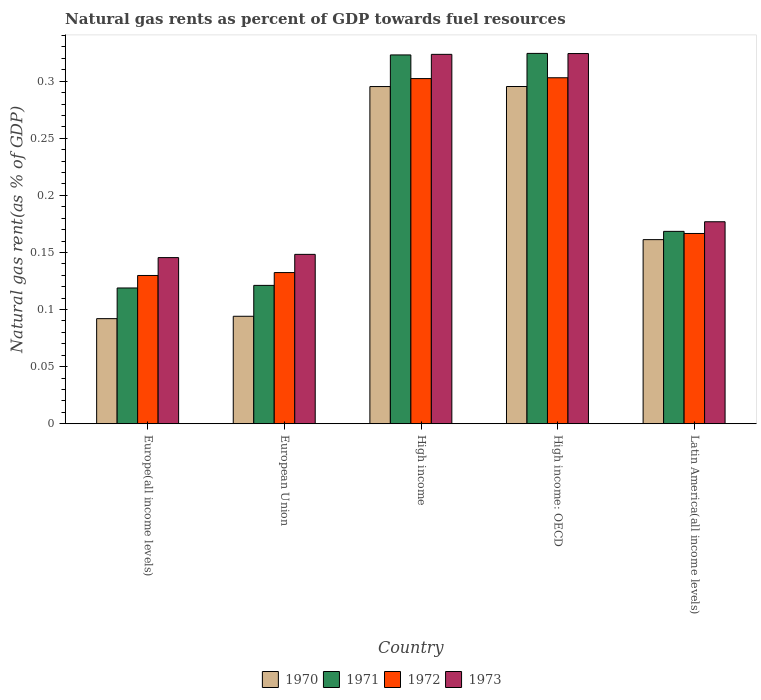How many different coloured bars are there?
Keep it short and to the point. 4. How many groups of bars are there?
Give a very brief answer. 5. Are the number of bars per tick equal to the number of legend labels?
Your answer should be very brief. Yes. Are the number of bars on each tick of the X-axis equal?
Your answer should be compact. Yes. How many bars are there on the 4th tick from the left?
Offer a very short reply. 4. What is the label of the 1st group of bars from the left?
Your answer should be very brief. Europe(all income levels). What is the natural gas rent in 1971 in High income: OECD?
Provide a short and direct response. 0.32. Across all countries, what is the maximum natural gas rent in 1973?
Your answer should be compact. 0.32. Across all countries, what is the minimum natural gas rent in 1971?
Give a very brief answer. 0.12. In which country was the natural gas rent in 1970 maximum?
Your answer should be compact. High income: OECD. In which country was the natural gas rent in 1970 minimum?
Offer a terse response. Europe(all income levels). What is the total natural gas rent in 1970 in the graph?
Keep it short and to the point. 0.94. What is the difference between the natural gas rent in 1970 in European Union and that in High income: OECD?
Keep it short and to the point. -0.2. What is the difference between the natural gas rent in 1972 in Europe(all income levels) and the natural gas rent in 1970 in European Union?
Your response must be concise. 0.04. What is the average natural gas rent in 1972 per country?
Ensure brevity in your answer.  0.21. What is the difference between the natural gas rent of/in 1973 and natural gas rent of/in 1971 in Europe(all income levels)?
Offer a very short reply. 0.03. What is the ratio of the natural gas rent in 1971 in Europe(all income levels) to that in Latin America(all income levels)?
Your answer should be compact. 0.71. What is the difference between the highest and the second highest natural gas rent in 1970?
Provide a short and direct response. 0.13. What is the difference between the highest and the lowest natural gas rent in 1972?
Provide a short and direct response. 0.17. In how many countries, is the natural gas rent in 1973 greater than the average natural gas rent in 1973 taken over all countries?
Offer a very short reply. 2. What does the 3rd bar from the left in Europe(all income levels) represents?
Your answer should be compact. 1972. What does the 1st bar from the right in High income represents?
Provide a short and direct response. 1973. How many bars are there?
Your response must be concise. 20. How many countries are there in the graph?
Ensure brevity in your answer.  5. What is the difference between two consecutive major ticks on the Y-axis?
Ensure brevity in your answer.  0.05. Are the values on the major ticks of Y-axis written in scientific E-notation?
Keep it short and to the point. No. Does the graph contain any zero values?
Ensure brevity in your answer.  No. Where does the legend appear in the graph?
Offer a very short reply. Bottom center. How many legend labels are there?
Offer a terse response. 4. How are the legend labels stacked?
Offer a terse response. Horizontal. What is the title of the graph?
Offer a terse response. Natural gas rents as percent of GDP towards fuel resources. What is the label or title of the X-axis?
Provide a short and direct response. Country. What is the label or title of the Y-axis?
Make the answer very short. Natural gas rent(as % of GDP). What is the Natural gas rent(as % of GDP) in 1970 in Europe(all income levels)?
Your response must be concise. 0.09. What is the Natural gas rent(as % of GDP) of 1971 in Europe(all income levels)?
Your answer should be very brief. 0.12. What is the Natural gas rent(as % of GDP) of 1972 in Europe(all income levels)?
Provide a succinct answer. 0.13. What is the Natural gas rent(as % of GDP) of 1973 in Europe(all income levels)?
Ensure brevity in your answer.  0.15. What is the Natural gas rent(as % of GDP) of 1970 in European Union?
Provide a short and direct response. 0.09. What is the Natural gas rent(as % of GDP) of 1971 in European Union?
Ensure brevity in your answer.  0.12. What is the Natural gas rent(as % of GDP) in 1972 in European Union?
Provide a succinct answer. 0.13. What is the Natural gas rent(as % of GDP) of 1973 in European Union?
Offer a terse response. 0.15. What is the Natural gas rent(as % of GDP) in 1970 in High income?
Keep it short and to the point. 0.3. What is the Natural gas rent(as % of GDP) of 1971 in High income?
Offer a terse response. 0.32. What is the Natural gas rent(as % of GDP) in 1972 in High income?
Give a very brief answer. 0.3. What is the Natural gas rent(as % of GDP) in 1973 in High income?
Your response must be concise. 0.32. What is the Natural gas rent(as % of GDP) in 1970 in High income: OECD?
Give a very brief answer. 0.3. What is the Natural gas rent(as % of GDP) in 1971 in High income: OECD?
Ensure brevity in your answer.  0.32. What is the Natural gas rent(as % of GDP) of 1972 in High income: OECD?
Your answer should be very brief. 0.3. What is the Natural gas rent(as % of GDP) of 1973 in High income: OECD?
Keep it short and to the point. 0.32. What is the Natural gas rent(as % of GDP) in 1970 in Latin America(all income levels)?
Offer a terse response. 0.16. What is the Natural gas rent(as % of GDP) of 1971 in Latin America(all income levels)?
Offer a very short reply. 0.17. What is the Natural gas rent(as % of GDP) of 1972 in Latin America(all income levels)?
Provide a succinct answer. 0.17. What is the Natural gas rent(as % of GDP) of 1973 in Latin America(all income levels)?
Offer a terse response. 0.18. Across all countries, what is the maximum Natural gas rent(as % of GDP) in 1970?
Keep it short and to the point. 0.3. Across all countries, what is the maximum Natural gas rent(as % of GDP) in 1971?
Keep it short and to the point. 0.32. Across all countries, what is the maximum Natural gas rent(as % of GDP) in 1972?
Offer a terse response. 0.3. Across all countries, what is the maximum Natural gas rent(as % of GDP) in 1973?
Ensure brevity in your answer.  0.32. Across all countries, what is the minimum Natural gas rent(as % of GDP) in 1970?
Offer a terse response. 0.09. Across all countries, what is the minimum Natural gas rent(as % of GDP) in 1971?
Your answer should be very brief. 0.12. Across all countries, what is the minimum Natural gas rent(as % of GDP) in 1972?
Keep it short and to the point. 0.13. Across all countries, what is the minimum Natural gas rent(as % of GDP) in 1973?
Offer a terse response. 0.15. What is the total Natural gas rent(as % of GDP) in 1970 in the graph?
Offer a very short reply. 0.94. What is the total Natural gas rent(as % of GDP) in 1971 in the graph?
Ensure brevity in your answer.  1.06. What is the total Natural gas rent(as % of GDP) in 1972 in the graph?
Your answer should be compact. 1.03. What is the total Natural gas rent(as % of GDP) of 1973 in the graph?
Provide a succinct answer. 1.12. What is the difference between the Natural gas rent(as % of GDP) in 1970 in Europe(all income levels) and that in European Union?
Give a very brief answer. -0. What is the difference between the Natural gas rent(as % of GDP) in 1971 in Europe(all income levels) and that in European Union?
Your response must be concise. -0. What is the difference between the Natural gas rent(as % of GDP) in 1972 in Europe(all income levels) and that in European Union?
Offer a very short reply. -0. What is the difference between the Natural gas rent(as % of GDP) in 1973 in Europe(all income levels) and that in European Union?
Offer a terse response. -0. What is the difference between the Natural gas rent(as % of GDP) in 1970 in Europe(all income levels) and that in High income?
Give a very brief answer. -0.2. What is the difference between the Natural gas rent(as % of GDP) in 1971 in Europe(all income levels) and that in High income?
Your answer should be very brief. -0.2. What is the difference between the Natural gas rent(as % of GDP) in 1972 in Europe(all income levels) and that in High income?
Your answer should be very brief. -0.17. What is the difference between the Natural gas rent(as % of GDP) of 1973 in Europe(all income levels) and that in High income?
Provide a succinct answer. -0.18. What is the difference between the Natural gas rent(as % of GDP) of 1970 in Europe(all income levels) and that in High income: OECD?
Your response must be concise. -0.2. What is the difference between the Natural gas rent(as % of GDP) of 1971 in Europe(all income levels) and that in High income: OECD?
Keep it short and to the point. -0.21. What is the difference between the Natural gas rent(as % of GDP) in 1972 in Europe(all income levels) and that in High income: OECD?
Keep it short and to the point. -0.17. What is the difference between the Natural gas rent(as % of GDP) in 1973 in Europe(all income levels) and that in High income: OECD?
Provide a short and direct response. -0.18. What is the difference between the Natural gas rent(as % of GDP) of 1970 in Europe(all income levels) and that in Latin America(all income levels)?
Offer a very short reply. -0.07. What is the difference between the Natural gas rent(as % of GDP) of 1971 in Europe(all income levels) and that in Latin America(all income levels)?
Your response must be concise. -0.05. What is the difference between the Natural gas rent(as % of GDP) of 1972 in Europe(all income levels) and that in Latin America(all income levels)?
Make the answer very short. -0.04. What is the difference between the Natural gas rent(as % of GDP) in 1973 in Europe(all income levels) and that in Latin America(all income levels)?
Make the answer very short. -0.03. What is the difference between the Natural gas rent(as % of GDP) of 1970 in European Union and that in High income?
Provide a short and direct response. -0.2. What is the difference between the Natural gas rent(as % of GDP) in 1971 in European Union and that in High income?
Ensure brevity in your answer.  -0.2. What is the difference between the Natural gas rent(as % of GDP) in 1972 in European Union and that in High income?
Your response must be concise. -0.17. What is the difference between the Natural gas rent(as % of GDP) in 1973 in European Union and that in High income?
Offer a terse response. -0.18. What is the difference between the Natural gas rent(as % of GDP) in 1970 in European Union and that in High income: OECD?
Offer a terse response. -0.2. What is the difference between the Natural gas rent(as % of GDP) in 1971 in European Union and that in High income: OECD?
Give a very brief answer. -0.2. What is the difference between the Natural gas rent(as % of GDP) in 1972 in European Union and that in High income: OECD?
Your answer should be compact. -0.17. What is the difference between the Natural gas rent(as % of GDP) of 1973 in European Union and that in High income: OECD?
Offer a terse response. -0.18. What is the difference between the Natural gas rent(as % of GDP) in 1970 in European Union and that in Latin America(all income levels)?
Your answer should be compact. -0.07. What is the difference between the Natural gas rent(as % of GDP) in 1971 in European Union and that in Latin America(all income levels)?
Make the answer very short. -0.05. What is the difference between the Natural gas rent(as % of GDP) of 1972 in European Union and that in Latin America(all income levels)?
Make the answer very short. -0.03. What is the difference between the Natural gas rent(as % of GDP) of 1973 in European Union and that in Latin America(all income levels)?
Offer a terse response. -0.03. What is the difference between the Natural gas rent(as % of GDP) in 1971 in High income and that in High income: OECD?
Your response must be concise. -0. What is the difference between the Natural gas rent(as % of GDP) of 1972 in High income and that in High income: OECD?
Your answer should be compact. -0. What is the difference between the Natural gas rent(as % of GDP) in 1973 in High income and that in High income: OECD?
Your answer should be very brief. -0. What is the difference between the Natural gas rent(as % of GDP) in 1970 in High income and that in Latin America(all income levels)?
Give a very brief answer. 0.13. What is the difference between the Natural gas rent(as % of GDP) of 1971 in High income and that in Latin America(all income levels)?
Your answer should be compact. 0.15. What is the difference between the Natural gas rent(as % of GDP) in 1972 in High income and that in Latin America(all income levels)?
Keep it short and to the point. 0.14. What is the difference between the Natural gas rent(as % of GDP) in 1973 in High income and that in Latin America(all income levels)?
Provide a succinct answer. 0.15. What is the difference between the Natural gas rent(as % of GDP) of 1970 in High income: OECD and that in Latin America(all income levels)?
Provide a succinct answer. 0.13. What is the difference between the Natural gas rent(as % of GDP) of 1971 in High income: OECD and that in Latin America(all income levels)?
Provide a succinct answer. 0.16. What is the difference between the Natural gas rent(as % of GDP) in 1972 in High income: OECD and that in Latin America(all income levels)?
Provide a succinct answer. 0.14. What is the difference between the Natural gas rent(as % of GDP) of 1973 in High income: OECD and that in Latin America(all income levels)?
Offer a terse response. 0.15. What is the difference between the Natural gas rent(as % of GDP) in 1970 in Europe(all income levels) and the Natural gas rent(as % of GDP) in 1971 in European Union?
Give a very brief answer. -0.03. What is the difference between the Natural gas rent(as % of GDP) of 1970 in Europe(all income levels) and the Natural gas rent(as % of GDP) of 1972 in European Union?
Provide a short and direct response. -0.04. What is the difference between the Natural gas rent(as % of GDP) in 1970 in Europe(all income levels) and the Natural gas rent(as % of GDP) in 1973 in European Union?
Make the answer very short. -0.06. What is the difference between the Natural gas rent(as % of GDP) in 1971 in Europe(all income levels) and the Natural gas rent(as % of GDP) in 1972 in European Union?
Your answer should be very brief. -0.01. What is the difference between the Natural gas rent(as % of GDP) of 1971 in Europe(all income levels) and the Natural gas rent(as % of GDP) of 1973 in European Union?
Provide a short and direct response. -0.03. What is the difference between the Natural gas rent(as % of GDP) in 1972 in Europe(all income levels) and the Natural gas rent(as % of GDP) in 1973 in European Union?
Provide a short and direct response. -0.02. What is the difference between the Natural gas rent(as % of GDP) of 1970 in Europe(all income levels) and the Natural gas rent(as % of GDP) of 1971 in High income?
Provide a succinct answer. -0.23. What is the difference between the Natural gas rent(as % of GDP) of 1970 in Europe(all income levels) and the Natural gas rent(as % of GDP) of 1972 in High income?
Make the answer very short. -0.21. What is the difference between the Natural gas rent(as % of GDP) of 1970 in Europe(all income levels) and the Natural gas rent(as % of GDP) of 1973 in High income?
Ensure brevity in your answer.  -0.23. What is the difference between the Natural gas rent(as % of GDP) of 1971 in Europe(all income levels) and the Natural gas rent(as % of GDP) of 1972 in High income?
Keep it short and to the point. -0.18. What is the difference between the Natural gas rent(as % of GDP) in 1971 in Europe(all income levels) and the Natural gas rent(as % of GDP) in 1973 in High income?
Ensure brevity in your answer.  -0.2. What is the difference between the Natural gas rent(as % of GDP) of 1972 in Europe(all income levels) and the Natural gas rent(as % of GDP) of 1973 in High income?
Provide a short and direct response. -0.19. What is the difference between the Natural gas rent(as % of GDP) of 1970 in Europe(all income levels) and the Natural gas rent(as % of GDP) of 1971 in High income: OECD?
Offer a very short reply. -0.23. What is the difference between the Natural gas rent(as % of GDP) of 1970 in Europe(all income levels) and the Natural gas rent(as % of GDP) of 1972 in High income: OECD?
Make the answer very short. -0.21. What is the difference between the Natural gas rent(as % of GDP) in 1970 in Europe(all income levels) and the Natural gas rent(as % of GDP) in 1973 in High income: OECD?
Ensure brevity in your answer.  -0.23. What is the difference between the Natural gas rent(as % of GDP) in 1971 in Europe(all income levels) and the Natural gas rent(as % of GDP) in 1972 in High income: OECD?
Ensure brevity in your answer.  -0.18. What is the difference between the Natural gas rent(as % of GDP) of 1971 in Europe(all income levels) and the Natural gas rent(as % of GDP) of 1973 in High income: OECD?
Give a very brief answer. -0.21. What is the difference between the Natural gas rent(as % of GDP) in 1972 in Europe(all income levels) and the Natural gas rent(as % of GDP) in 1973 in High income: OECD?
Offer a very short reply. -0.19. What is the difference between the Natural gas rent(as % of GDP) of 1970 in Europe(all income levels) and the Natural gas rent(as % of GDP) of 1971 in Latin America(all income levels)?
Offer a very short reply. -0.08. What is the difference between the Natural gas rent(as % of GDP) in 1970 in Europe(all income levels) and the Natural gas rent(as % of GDP) in 1972 in Latin America(all income levels)?
Give a very brief answer. -0.07. What is the difference between the Natural gas rent(as % of GDP) of 1970 in Europe(all income levels) and the Natural gas rent(as % of GDP) of 1973 in Latin America(all income levels)?
Your answer should be compact. -0.08. What is the difference between the Natural gas rent(as % of GDP) of 1971 in Europe(all income levels) and the Natural gas rent(as % of GDP) of 1972 in Latin America(all income levels)?
Provide a succinct answer. -0.05. What is the difference between the Natural gas rent(as % of GDP) of 1971 in Europe(all income levels) and the Natural gas rent(as % of GDP) of 1973 in Latin America(all income levels)?
Your answer should be compact. -0.06. What is the difference between the Natural gas rent(as % of GDP) of 1972 in Europe(all income levels) and the Natural gas rent(as % of GDP) of 1973 in Latin America(all income levels)?
Offer a very short reply. -0.05. What is the difference between the Natural gas rent(as % of GDP) of 1970 in European Union and the Natural gas rent(as % of GDP) of 1971 in High income?
Your response must be concise. -0.23. What is the difference between the Natural gas rent(as % of GDP) of 1970 in European Union and the Natural gas rent(as % of GDP) of 1972 in High income?
Make the answer very short. -0.21. What is the difference between the Natural gas rent(as % of GDP) of 1970 in European Union and the Natural gas rent(as % of GDP) of 1973 in High income?
Keep it short and to the point. -0.23. What is the difference between the Natural gas rent(as % of GDP) of 1971 in European Union and the Natural gas rent(as % of GDP) of 1972 in High income?
Offer a very short reply. -0.18. What is the difference between the Natural gas rent(as % of GDP) in 1971 in European Union and the Natural gas rent(as % of GDP) in 1973 in High income?
Your response must be concise. -0.2. What is the difference between the Natural gas rent(as % of GDP) of 1972 in European Union and the Natural gas rent(as % of GDP) of 1973 in High income?
Your response must be concise. -0.19. What is the difference between the Natural gas rent(as % of GDP) in 1970 in European Union and the Natural gas rent(as % of GDP) in 1971 in High income: OECD?
Make the answer very short. -0.23. What is the difference between the Natural gas rent(as % of GDP) of 1970 in European Union and the Natural gas rent(as % of GDP) of 1972 in High income: OECD?
Offer a terse response. -0.21. What is the difference between the Natural gas rent(as % of GDP) in 1970 in European Union and the Natural gas rent(as % of GDP) in 1973 in High income: OECD?
Your response must be concise. -0.23. What is the difference between the Natural gas rent(as % of GDP) of 1971 in European Union and the Natural gas rent(as % of GDP) of 1972 in High income: OECD?
Your answer should be compact. -0.18. What is the difference between the Natural gas rent(as % of GDP) of 1971 in European Union and the Natural gas rent(as % of GDP) of 1973 in High income: OECD?
Make the answer very short. -0.2. What is the difference between the Natural gas rent(as % of GDP) of 1972 in European Union and the Natural gas rent(as % of GDP) of 1973 in High income: OECD?
Your response must be concise. -0.19. What is the difference between the Natural gas rent(as % of GDP) of 1970 in European Union and the Natural gas rent(as % of GDP) of 1971 in Latin America(all income levels)?
Provide a short and direct response. -0.07. What is the difference between the Natural gas rent(as % of GDP) in 1970 in European Union and the Natural gas rent(as % of GDP) in 1972 in Latin America(all income levels)?
Your answer should be compact. -0.07. What is the difference between the Natural gas rent(as % of GDP) of 1970 in European Union and the Natural gas rent(as % of GDP) of 1973 in Latin America(all income levels)?
Your answer should be very brief. -0.08. What is the difference between the Natural gas rent(as % of GDP) of 1971 in European Union and the Natural gas rent(as % of GDP) of 1972 in Latin America(all income levels)?
Provide a short and direct response. -0.05. What is the difference between the Natural gas rent(as % of GDP) in 1971 in European Union and the Natural gas rent(as % of GDP) in 1973 in Latin America(all income levels)?
Offer a terse response. -0.06. What is the difference between the Natural gas rent(as % of GDP) in 1972 in European Union and the Natural gas rent(as % of GDP) in 1973 in Latin America(all income levels)?
Your answer should be compact. -0.04. What is the difference between the Natural gas rent(as % of GDP) of 1970 in High income and the Natural gas rent(as % of GDP) of 1971 in High income: OECD?
Offer a very short reply. -0.03. What is the difference between the Natural gas rent(as % of GDP) of 1970 in High income and the Natural gas rent(as % of GDP) of 1972 in High income: OECD?
Keep it short and to the point. -0.01. What is the difference between the Natural gas rent(as % of GDP) in 1970 in High income and the Natural gas rent(as % of GDP) in 1973 in High income: OECD?
Keep it short and to the point. -0.03. What is the difference between the Natural gas rent(as % of GDP) in 1971 in High income and the Natural gas rent(as % of GDP) in 1972 in High income: OECD?
Offer a very short reply. 0.02. What is the difference between the Natural gas rent(as % of GDP) in 1971 in High income and the Natural gas rent(as % of GDP) in 1973 in High income: OECD?
Give a very brief answer. -0. What is the difference between the Natural gas rent(as % of GDP) in 1972 in High income and the Natural gas rent(as % of GDP) in 1973 in High income: OECD?
Provide a short and direct response. -0.02. What is the difference between the Natural gas rent(as % of GDP) of 1970 in High income and the Natural gas rent(as % of GDP) of 1971 in Latin America(all income levels)?
Your answer should be very brief. 0.13. What is the difference between the Natural gas rent(as % of GDP) in 1970 in High income and the Natural gas rent(as % of GDP) in 1972 in Latin America(all income levels)?
Offer a terse response. 0.13. What is the difference between the Natural gas rent(as % of GDP) of 1970 in High income and the Natural gas rent(as % of GDP) of 1973 in Latin America(all income levels)?
Your answer should be very brief. 0.12. What is the difference between the Natural gas rent(as % of GDP) in 1971 in High income and the Natural gas rent(as % of GDP) in 1972 in Latin America(all income levels)?
Keep it short and to the point. 0.16. What is the difference between the Natural gas rent(as % of GDP) of 1971 in High income and the Natural gas rent(as % of GDP) of 1973 in Latin America(all income levels)?
Make the answer very short. 0.15. What is the difference between the Natural gas rent(as % of GDP) of 1972 in High income and the Natural gas rent(as % of GDP) of 1973 in Latin America(all income levels)?
Your response must be concise. 0.13. What is the difference between the Natural gas rent(as % of GDP) in 1970 in High income: OECD and the Natural gas rent(as % of GDP) in 1971 in Latin America(all income levels)?
Give a very brief answer. 0.13. What is the difference between the Natural gas rent(as % of GDP) of 1970 in High income: OECD and the Natural gas rent(as % of GDP) of 1972 in Latin America(all income levels)?
Keep it short and to the point. 0.13. What is the difference between the Natural gas rent(as % of GDP) of 1970 in High income: OECD and the Natural gas rent(as % of GDP) of 1973 in Latin America(all income levels)?
Offer a very short reply. 0.12. What is the difference between the Natural gas rent(as % of GDP) of 1971 in High income: OECD and the Natural gas rent(as % of GDP) of 1972 in Latin America(all income levels)?
Ensure brevity in your answer.  0.16. What is the difference between the Natural gas rent(as % of GDP) in 1971 in High income: OECD and the Natural gas rent(as % of GDP) in 1973 in Latin America(all income levels)?
Offer a very short reply. 0.15. What is the difference between the Natural gas rent(as % of GDP) in 1972 in High income: OECD and the Natural gas rent(as % of GDP) in 1973 in Latin America(all income levels)?
Give a very brief answer. 0.13. What is the average Natural gas rent(as % of GDP) of 1970 per country?
Keep it short and to the point. 0.19. What is the average Natural gas rent(as % of GDP) in 1971 per country?
Give a very brief answer. 0.21. What is the average Natural gas rent(as % of GDP) in 1972 per country?
Provide a short and direct response. 0.21. What is the average Natural gas rent(as % of GDP) in 1973 per country?
Give a very brief answer. 0.22. What is the difference between the Natural gas rent(as % of GDP) in 1970 and Natural gas rent(as % of GDP) in 1971 in Europe(all income levels)?
Make the answer very short. -0.03. What is the difference between the Natural gas rent(as % of GDP) of 1970 and Natural gas rent(as % of GDP) of 1972 in Europe(all income levels)?
Offer a terse response. -0.04. What is the difference between the Natural gas rent(as % of GDP) of 1970 and Natural gas rent(as % of GDP) of 1973 in Europe(all income levels)?
Give a very brief answer. -0.05. What is the difference between the Natural gas rent(as % of GDP) of 1971 and Natural gas rent(as % of GDP) of 1972 in Europe(all income levels)?
Your answer should be compact. -0.01. What is the difference between the Natural gas rent(as % of GDP) of 1971 and Natural gas rent(as % of GDP) of 1973 in Europe(all income levels)?
Provide a short and direct response. -0.03. What is the difference between the Natural gas rent(as % of GDP) of 1972 and Natural gas rent(as % of GDP) of 1973 in Europe(all income levels)?
Your answer should be very brief. -0.02. What is the difference between the Natural gas rent(as % of GDP) of 1970 and Natural gas rent(as % of GDP) of 1971 in European Union?
Your response must be concise. -0.03. What is the difference between the Natural gas rent(as % of GDP) of 1970 and Natural gas rent(as % of GDP) of 1972 in European Union?
Provide a short and direct response. -0.04. What is the difference between the Natural gas rent(as % of GDP) of 1970 and Natural gas rent(as % of GDP) of 1973 in European Union?
Your answer should be very brief. -0.05. What is the difference between the Natural gas rent(as % of GDP) of 1971 and Natural gas rent(as % of GDP) of 1972 in European Union?
Ensure brevity in your answer.  -0.01. What is the difference between the Natural gas rent(as % of GDP) of 1971 and Natural gas rent(as % of GDP) of 1973 in European Union?
Ensure brevity in your answer.  -0.03. What is the difference between the Natural gas rent(as % of GDP) in 1972 and Natural gas rent(as % of GDP) in 1973 in European Union?
Ensure brevity in your answer.  -0.02. What is the difference between the Natural gas rent(as % of GDP) in 1970 and Natural gas rent(as % of GDP) in 1971 in High income?
Provide a succinct answer. -0.03. What is the difference between the Natural gas rent(as % of GDP) in 1970 and Natural gas rent(as % of GDP) in 1972 in High income?
Your response must be concise. -0.01. What is the difference between the Natural gas rent(as % of GDP) in 1970 and Natural gas rent(as % of GDP) in 1973 in High income?
Your answer should be compact. -0.03. What is the difference between the Natural gas rent(as % of GDP) of 1971 and Natural gas rent(as % of GDP) of 1972 in High income?
Provide a short and direct response. 0.02. What is the difference between the Natural gas rent(as % of GDP) of 1971 and Natural gas rent(as % of GDP) of 1973 in High income?
Offer a terse response. -0. What is the difference between the Natural gas rent(as % of GDP) in 1972 and Natural gas rent(as % of GDP) in 1973 in High income?
Provide a short and direct response. -0.02. What is the difference between the Natural gas rent(as % of GDP) of 1970 and Natural gas rent(as % of GDP) of 1971 in High income: OECD?
Offer a terse response. -0.03. What is the difference between the Natural gas rent(as % of GDP) in 1970 and Natural gas rent(as % of GDP) in 1972 in High income: OECD?
Give a very brief answer. -0.01. What is the difference between the Natural gas rent(as % of GDP) in 1970 and Natural gas rent(as % of GDP) in 1973 in High income: OECD?
Your answer should be very brief. -0.03. What is the difference between the Natural gas rent(as % of GDP) of 1971 and Natural gas rent(as % of GDP) of 1972 in High income: OECD?
Give a very brief answer. 0.02. What is the difference between the Natural gas rent(as % of GDP) of 1972 and Natural gas rent(as % of GDP) of 1973 in High income: OECD?
Your response must be concise. -0.02. What is the difference between the Natural gas rent(as % of GDP) of 1970 and Natural gas rent(as % of GDP) of 1971 in Latin America(all income levels)?
Provide a short and direct response. -0.01. What is the difference between the Natural gas rent(as % of GDP) in 1970 and Natural gas rent(as % of GDP) in 1972 in Latin America(all income levels)?
Make the answer very short. -0.01. What is the difference between the Natural gas rent(as % of GDP) of 1970 and Natural gas rent(as % of GDP) of 1973 in Latin America(all income levels)?
Your response must be concise. -0.02. What is the difference between the Natural gas rent(as % of GDP) of 1971 and Natural gas rent(as % of GDP) of 1972 in Latin America(all income levels)?
Offer a very short reply. 0. What is the difference between the Natural gas rent(as % of GDP) in 1971 and Natural gas rent(as % of GDP) in 1973 in Latin America(all income levels)?
Give a very brief answer. -0.01. What is the difference between the Natural gas rent(as % of GDP) of 1972 and Natural gas rent(as % of GDP) of 1973 in Latin America(all income levels)?
Make the answer very short. -0.01. What is the ratio of the Natural gas rent(as % of GDP) of 1970 in Europe(all income levels) to that in European Union?
Your response must be concise. 0.98. What is the ratio of the Natural gas rent(as % of GDP) in 1971 in Europe(all income levels) to that in European Union?
Ensure brevity in your answer.  0.98. What is the ratio of the Natural gas rent(as % of GDP) of 1972 in Europe(all income levels) to that in European Union?
Ensure brevity in your answer.  0.98. What is the ratio of the Natural gas rent(as % of GDP) in 1973 in Europe(all income levels) to that in European Union?
Ensure brevity in your answer.  0.98. What is the ratio of the Natural gas rent(as % of GDP) in 1970 in Europe(all income levels) to that in High income?
Offer a very short reply. 0.31. What is the ratio of the Natural gas rent(as % of GDP) of 1971 in Europe(all income levels) to that in High income?
Make the answer very short. 0.37. What is the ratio of the Natural gas rent(as % of GDP) of 1972 in Europe(all income levels) to that in High income?
Keep it short and to the point. 0.43. What is the ratio of the Natural gas rent(as % of GDP) in 1973 in Europe(all income levels) to that in High income?
Your response must be concise. 0.45. What is the ratio of the Natural gas rent(as % of GDP) in 1970 in Europe(all income levels) to that in High income: OECD?
Offer a terse response. 0.31. What is the ratio of the Natural gas rent(as % of GDP) of 1971 in Europe(all income levels) to that in High income: OECD?
Offer a very short reply. 0.37. What is the ratio of the Natural gas rent(as % of GDP) in 1972 in Europe(all income levels) to that in High income: OECD?
Keep it short and to the point. 0.43. What is the ratio of the Natural gas rent(as % of GDP) in 1973 in Europe(all income levels) to that in High income: OECD?
Offer a very short reply. 0.45. What is the ratio of the Natural gas rent(as % of GDP) in 1970 in Europe(all income levels) to that in Latin America(all income levels)?
Provide a short and direct response. 0.57. What is the ratio of the Natural gas rent(as % of GDP) in 1971 in Europe(all income levels) to that in Latin America(all income levels)?
Offer a very short reply. 0.71. What is the ratio of the Natural gas rent(as % of GDP) of 1972 in Europe(all income levels) to that in Latin America(all income levels)?
Your response must be concise. 0.78. What is the ratio of the Natural gas rent(as % of GDP) of 1973 in Europe(all income levels) to that in Latin America(all income levels)?
Provide a short and direct response. 0.82. What is the ratio of the Natural gas rent(as % of GDP) in 1970 in European Union to that in High income?
Provide a succinct answer. 0.32. What is the ratio of the Natural gas rent(as % of GDP) of 1971 in European Union to that in High income?
Ensure brevity in your answer.  0.38. What is the ratio of the Natural gas rent(as % of GDP) in 1972 in European Union to that in High income?
Offer a very short reply. 0.44. What is the ratio of the Natural gas rent(as % of GDP) in 1973 in European Union to that in High income?
Make the answer very short. 0.46. What is the ratio of the Natural gas rent(as % of GDP) of 1970 in European Union to that in High income: OECD?
Your answer should be compact. 0.32. What is the ratio of the Natural gas rent(as % of GDP) in 1971 in European Union to that in High income: OECD?
Your answer should be very brief. 0.37. What is the ratio of the Natural gas rent(as % of GDP) of 1972 in European Union to that in High income: OECD?
Offer a very short reply. 0.44. What is the ratio of the Natural gas rent(as % of GDP) in 1973 in European Union to that in High income: OECD?
Offer a very short reply. 0.46. What is the ratio of the Natural gas rent(as % of GDP) in 1970 in European Union to that in Latin America(all income levels)?
Keep it short and to the point. 0.58. What is the ratio of the Natural gas rent(as % of GDP) in 1971 in European Union to that in Latin America(all income levels)?
Offer a very short reply. 0.72. What is the ratio of the Natural gas rent(as % of GDP) in 1972 in European Union to that in Latin America(all income levels)?
Make the answer very short. 0.79. What is the ratio of the Natural gas rent(as % of GDP) of 1973 in European Union to that in Latin America(all income levels)?
Ensure brevity in your answer.  0.84. What is the ratio of the Natural gas rent(as % of GDP) of 1970 in High income to that in High income: OECD?
Give a very brief answer. 1. What is the ratio of the Natural gas rent(as % of GDP) in 1970 in High income to that in Latin America(all income levels)?
Make the answer very short. 1.83. What is the ratio of the Natural gas rent(as % of GDP) in 1971 in High income to that in Latin America(all income levels)?
Keep it short and to the point. 1.92. What is the ratio of the Natural gas rent(as % of GDP) in 1972 in High income to that in Latin America(all income levels)?
Provide a succinct answer. 1.81. What is the ratio of the Natural gas rent(as % of GDP) in 1973 in High income to that in Latin America(all income levels)?
Your answer should be compact. 1.83. What is the ratio of the Natural gas rent(as % of GDP) in 1970 in High income: OECD to that in Latin America(all income levels)?
Offer a terse response. 1.83. What is the ratio of the Natural gas rent(as % of GDP) of 1971 in High income: OECD to that in Latin America(all income levels)?
Your answer should be very brief. 1.93. What is the ratio of the Natural gas rent(as % of GDP) of 1972 in High income: OECD to that in Latin America(all income levels)?
Provide a succinct answer. 1.82. What is the ratio of the Natural gas rent(as % of GDP) in 1973 in High income: OECD to that in Latin America(all income levels)?
Give a very brief answer. 1.83. What is the difference between the highest and the second highest Natural gas rent(as % of GDP) in 1970?
Ensure brevity in your answer.  0. What is the difference between the highest and the second highest Natural gas rent(as % of GDP) in 1971?
Offer a very short reply. 0. What is the difference between the highest and the second highest Natural gas rent(as % of GDP) in 1972?
Give a very brief answer. 0. What is the difference between the highest and the second highest Natural gas rent(as % of GDP) of 1973?
Offer a terse response. 0. What is the difference between the highest and the lowest Natural gas rent(as % of GDP) in 1970?
Your answer should be very brief. 0.2. What is the difference between the highest and the lowest Natural gas rent(as % of GDP) in 1971?
Keep it short and to the point. 0.21. What is the difference between the highest and the lowest Natural gas rent(as % of GDP) of 1972?
Ensure brevity in your answer.  0.17. What is the difference between the highest and the lowest Natural gas rent(as % of GDP) in 1973?
Your answer should be very brief. 0.18. 